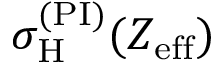<formula> <loc_0><loc_0><loc_500><loc_500>\sigma _ { H } ^ { ( P I ) } ( Z _ { e f f } )</formula> 